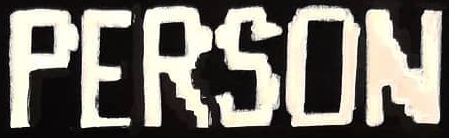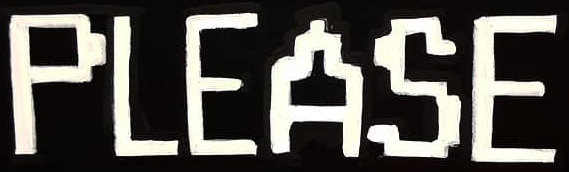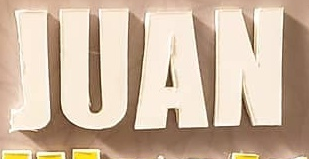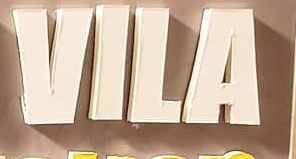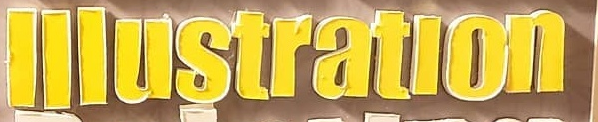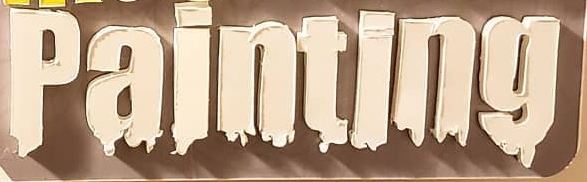Read the text content from these images in order, separated by a semicolon. PERSON; PLEASE; JUAN; VILA; lllustratlon; painting 